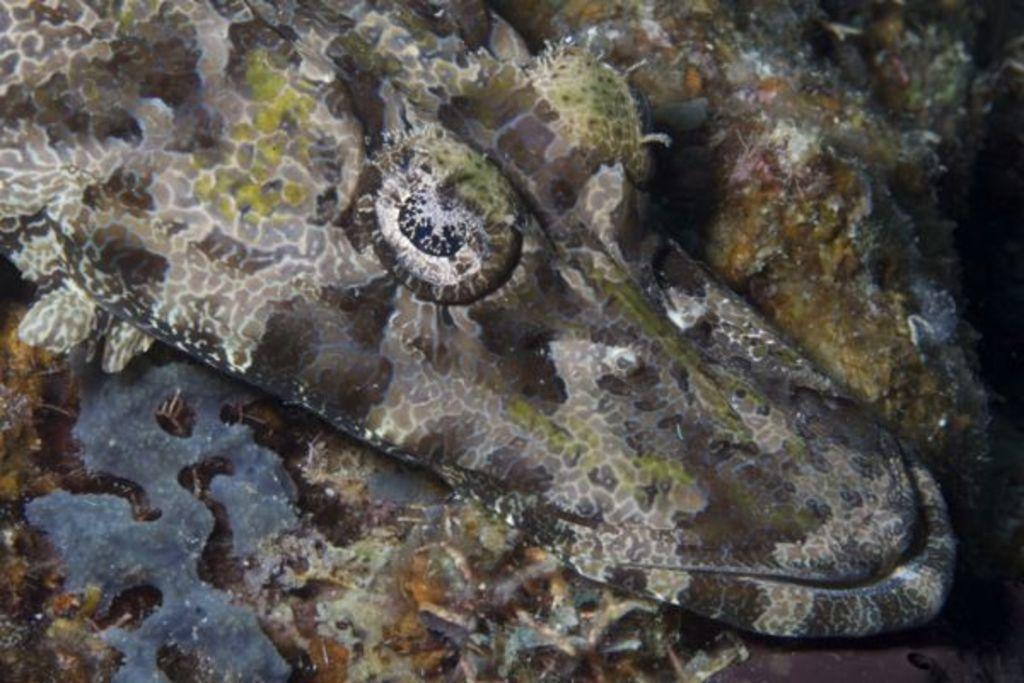What type of animal can be seen in the image? There is an aquatic animal in the image. Where is the aquatic animal located? The aquatic animal is on the ground. What can be seen in the background of the image? There is water visible in the image, covering the area. What type of van can be seen in the image? There is no van present in the image; it features an aquatic animal on the ground with water in the background. 